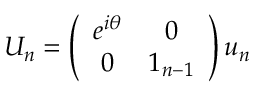<formula> <loc_0><loc_0><loc_500><loc_500>U _ { n } = \left ( \begin{array} { c c } { { e ^ { i \theta } } } & { 0 } \\ { 0 } & { { 1 _ { n - 1 } } } \end{array} \right ) u _ { n }</formula> 